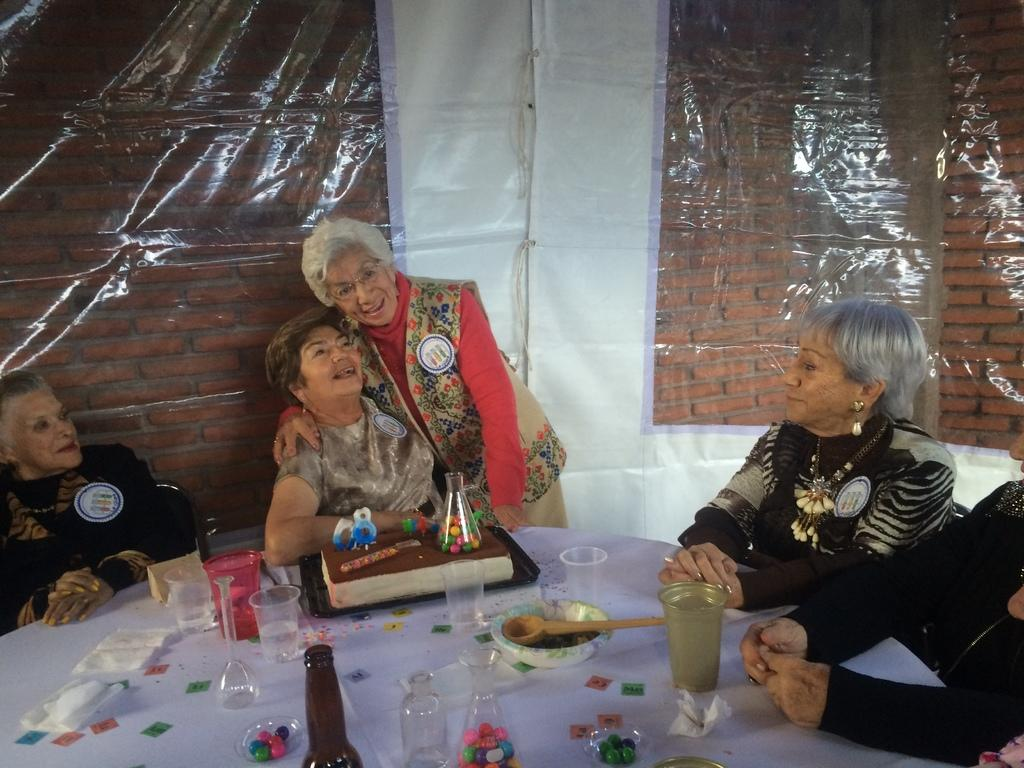What is happening with the group of women in the image? There is a group of women sitting in front of a table. What is the position of the woman standing in the image? The woman standing is in front of the table. What is the expression on the face of the woman standing? The woman standing is smiling. What can be found on the table in the image? There are bottles and other objects on the table. What type of cake is being served to the group of women in the image? There is no cake present in the image; only bottles and other objects are visible on the table. 